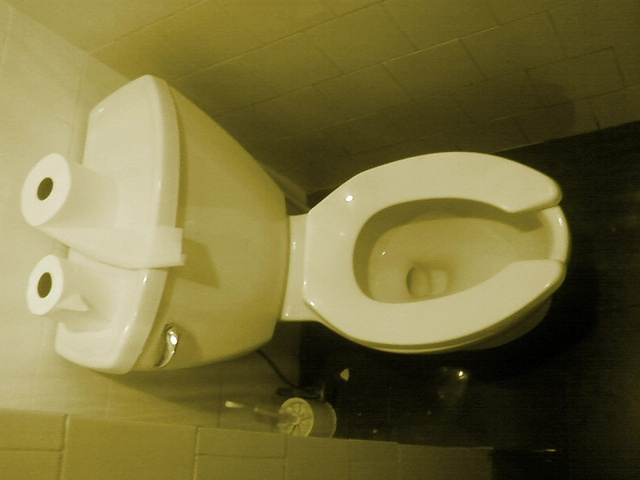Describe the objects in this image and their specific colors. I can see a toilet in tan and olive tones in this image. 